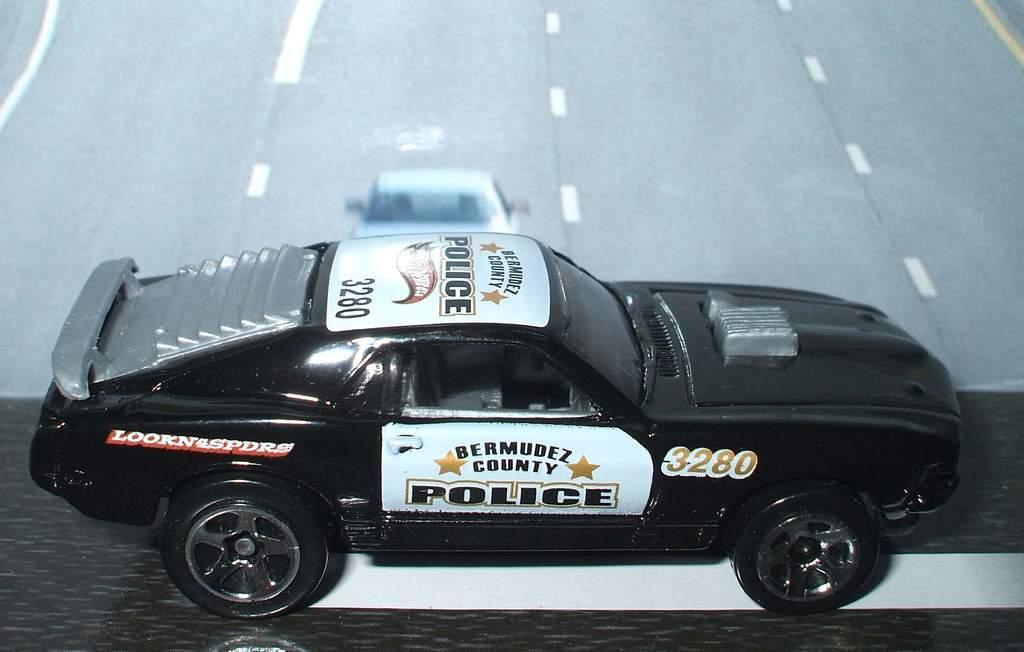Could you give a brief overview of what you see in this image? In this picture we can see cars in white and black color. This is a road. 